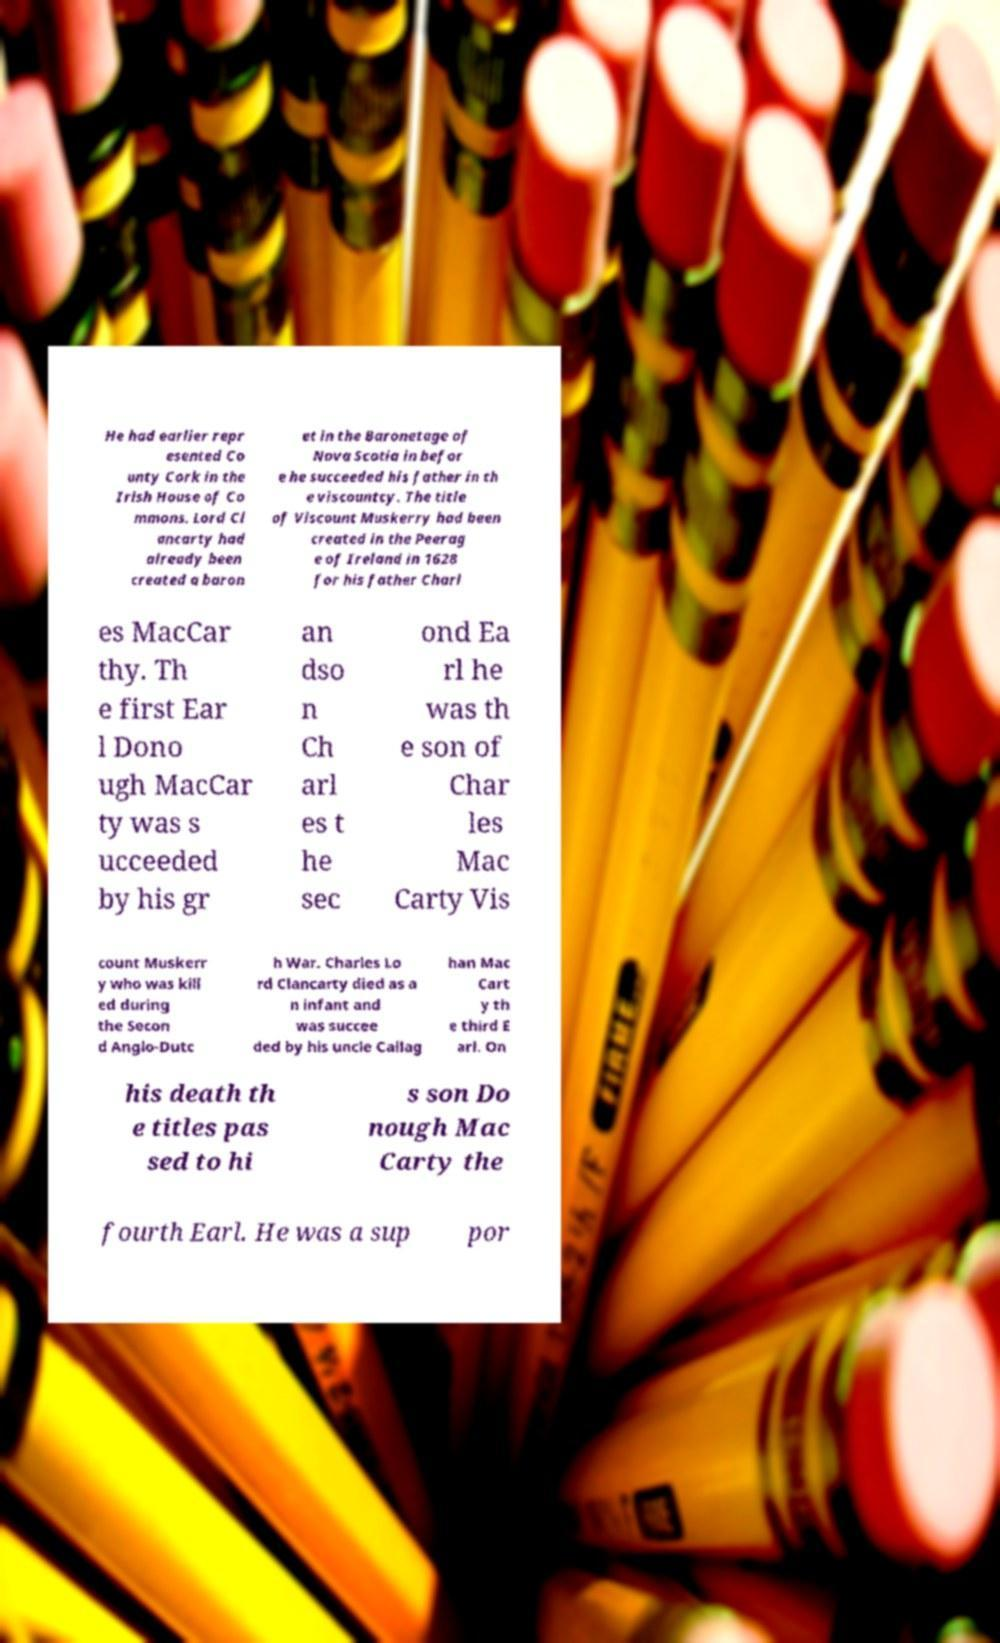Can you read and provide the text displayed in the image?This photo seems to have some interesting text. Can you extract and type it out for me? He had earlier repr esented Co unty Cork in the Irish House of Co mmons. Lord Cl ancarty had already been created a baron et in the Baronetage of Nova Scotia in befor e he succeeded his father in th e viscountcy. The title of Viscount Muskerry had been created in the Peerag e of Ireland in 1628 for his father Charl es MacCar thy. Th e first Ear l Dono ugh MacCar ty was s ucceeded by his gr an dso n Ch arl es t he sec ond Ea rl he was th e son of Char les Mac Carty Vis count Muskerr y who was kill ed during the Secon d Anglo-Dutc h War. Charles Lo rd Clancarty died as a n infant and was succee ded by his uncle Callag han Mac Cart y th e third E arl. On his death th e titles pas sed to hi s son Do nough Mac Carty the fourth Earl. He was a sup por 